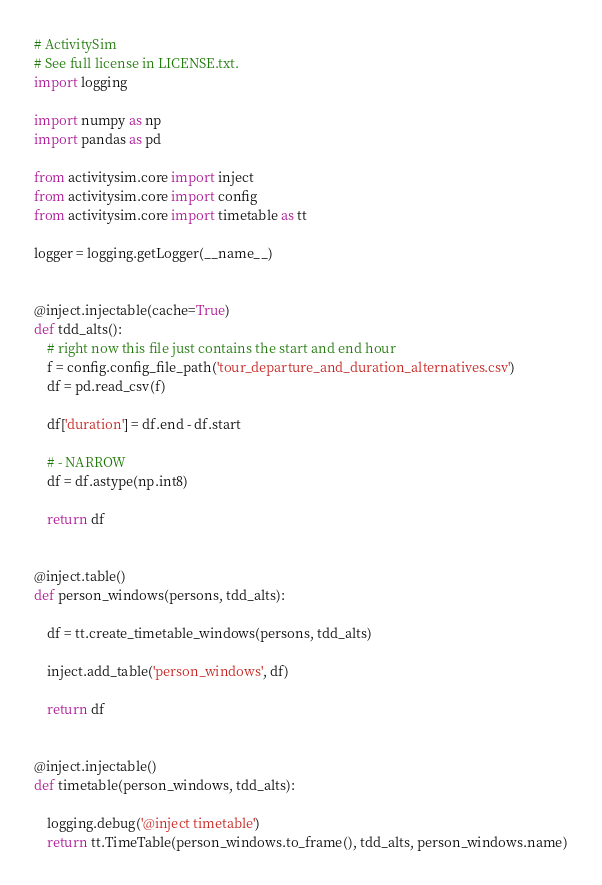<code> <loc_0><loc_0><loc_500><loc_500><_Python_># ActivitySim
# See full license in LICENSE.txt.
import logging

import numpy as np
import pandas as pd

from activitysim.core import inject
from activitysim.core import config
from activitysim.core import timetable as tt

logger = logging.getLogger(__name__)


@inject.injectable(cache=True)
def tdd_alts():
    # right now this file just contains the start and end hour
    f = config.config_file_path('tour_departure_and_duration_alternatives.csv')
    df = pd.read_csv(f)

    df['duration'] = df.end - df.start

    # - NARROW
    df = df.astype(np.int8)

    return df


@inject.table()
def person_windows(persons, tdd_alts):

    df = tt.create_timetable_windows(persons, tdd_alts)

    inject.add_table('person_windows', df)

    return df


@inject.injectable()
def timetable(person_windows, tdd_alts):

    logging.debug('@inject timetable')
    return tt.TimeTable(person_windows.to_frame(), tdd_alts, person_windows.name)
</code> 